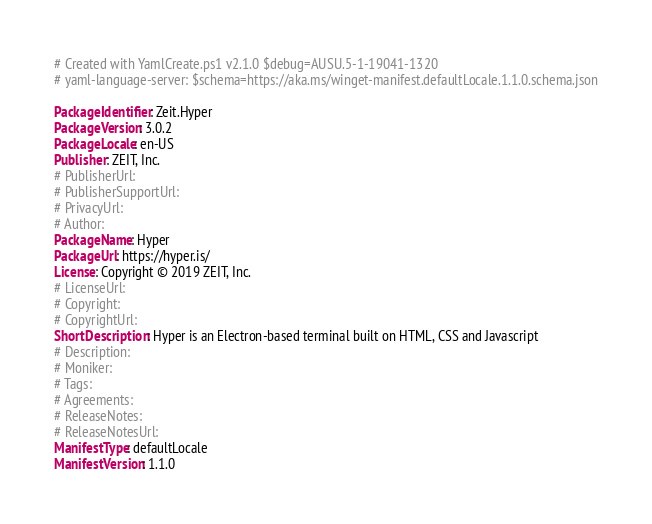Convert code to text. <code><loc_0><loc_0><loc_500><loc_500><_YAML_># Created with YamlCreate.ps1 v2.1.0 $debug=AUSU.5-1-19041-1320
# yaml-language-server: $schema=https://aka.ms/winget-manifest.defaultLocale.1.1.0.schema.json

PackageIdentifier: Zeit.Hyper
PackageVersion: 3.0.2
PackageLocale: en-US
Publisher: ZEIT, Inc.
# PublisherUrl: 
# PublisherSupportUrl: 
# PrivacyUrl: 
# Author: 
PackageName: Hyper
PackageUrl: https://hyper.is/
License: Copyright © 2019 ZEIT, Inc.
# LicenseUrl: 
# Copyright: 
# CopyrightUrl: 
ShortDescription: Hyper is an Electron-based terminal built on HTML, CSS and Javascript
# Description: 
# Moniker: 
# Tags: 
# Agreements: 
# ReleaseNotes: 
# ReleaseNotesUrl: 
ManifestType: defaultLocale
ManifestVersion: 1.1.0
</code> 